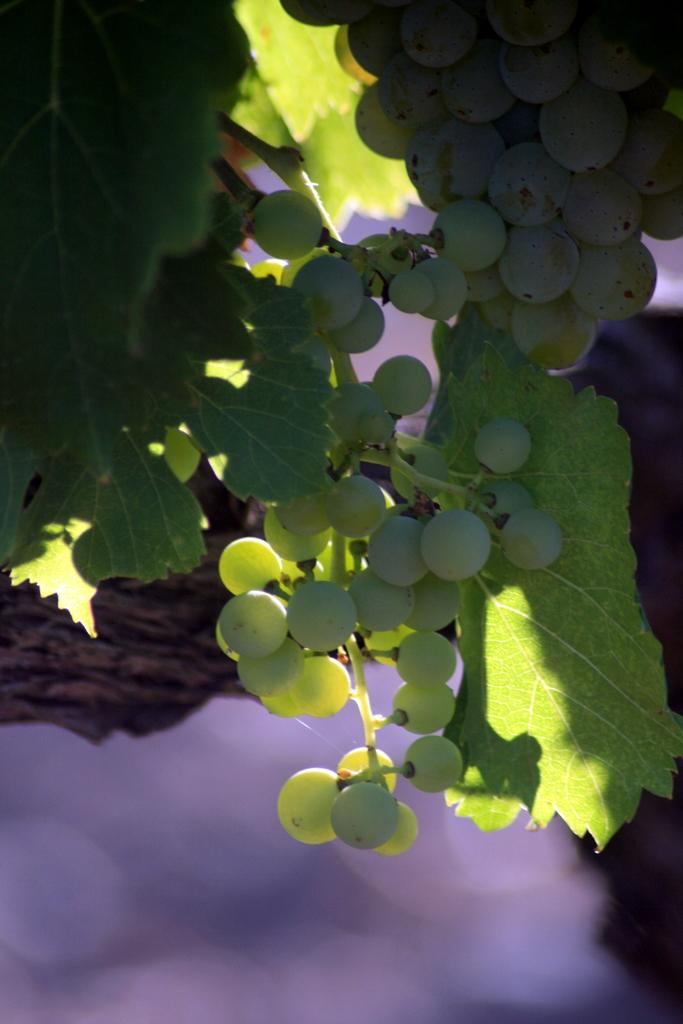What type of photography is used in the image? The image is a macro photography. What can be seen in the image besides the photography style? There are trees and fruits in the image. Who is the creator of the apples in the image? There are no apples present in the image, only fruits in general. What type of gun can be seen in the image? There is no gun present in the image. 